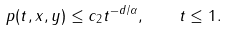<formula> <loc_0><loc_0><loc_500><loc_500>p ( t , x , y ) \leq c _ { 2 } t ^ { - d / \alpha } , \quad t \leq 1 .</formula> 